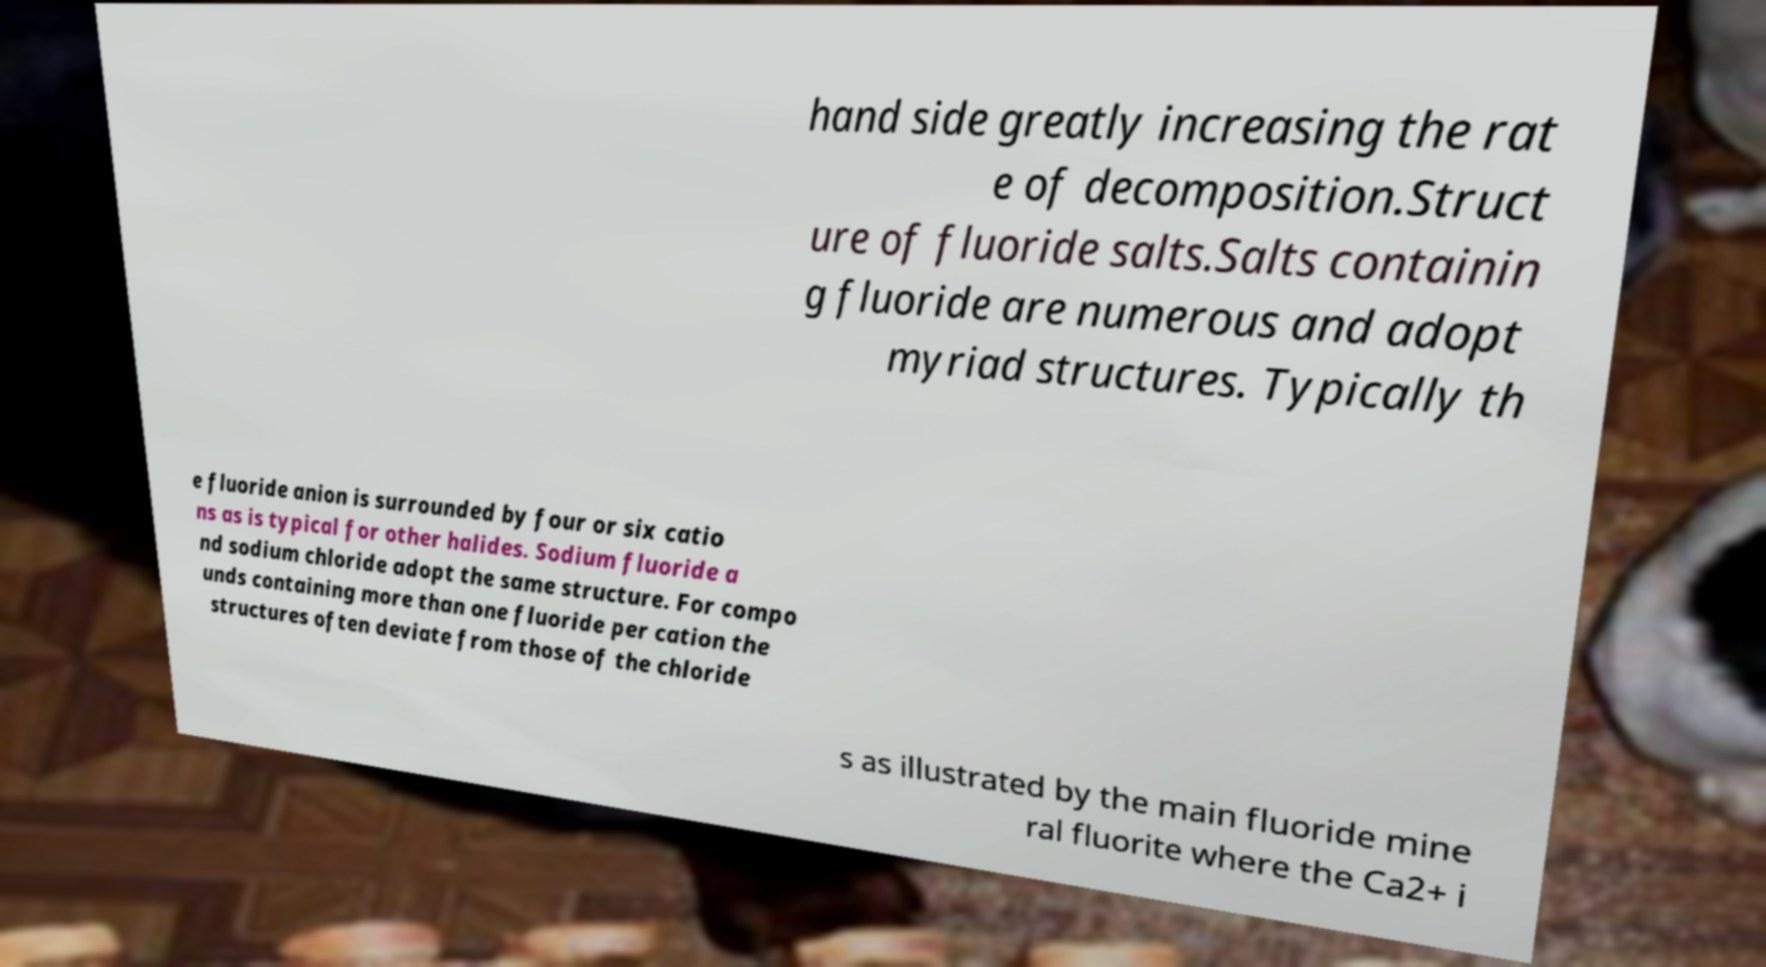Please identify and transcribe the text found in this image. hand side greatly increasing the rat e of decomposition.Struct ure of fluoride salts.Salts containin g fluoride are numerous and adopt myriad structures. Typically th e fluoride anion is surrounded by four or six catio ns as is typical for other halides. Sodium fluoride a nd sodium chloride adopt the same structure. For compo unds containing more than one fluoride per cation the structures often deviate from those of the chloride s as illustrated by the main fluoride mine ral fluorite where the Ca2+ i 